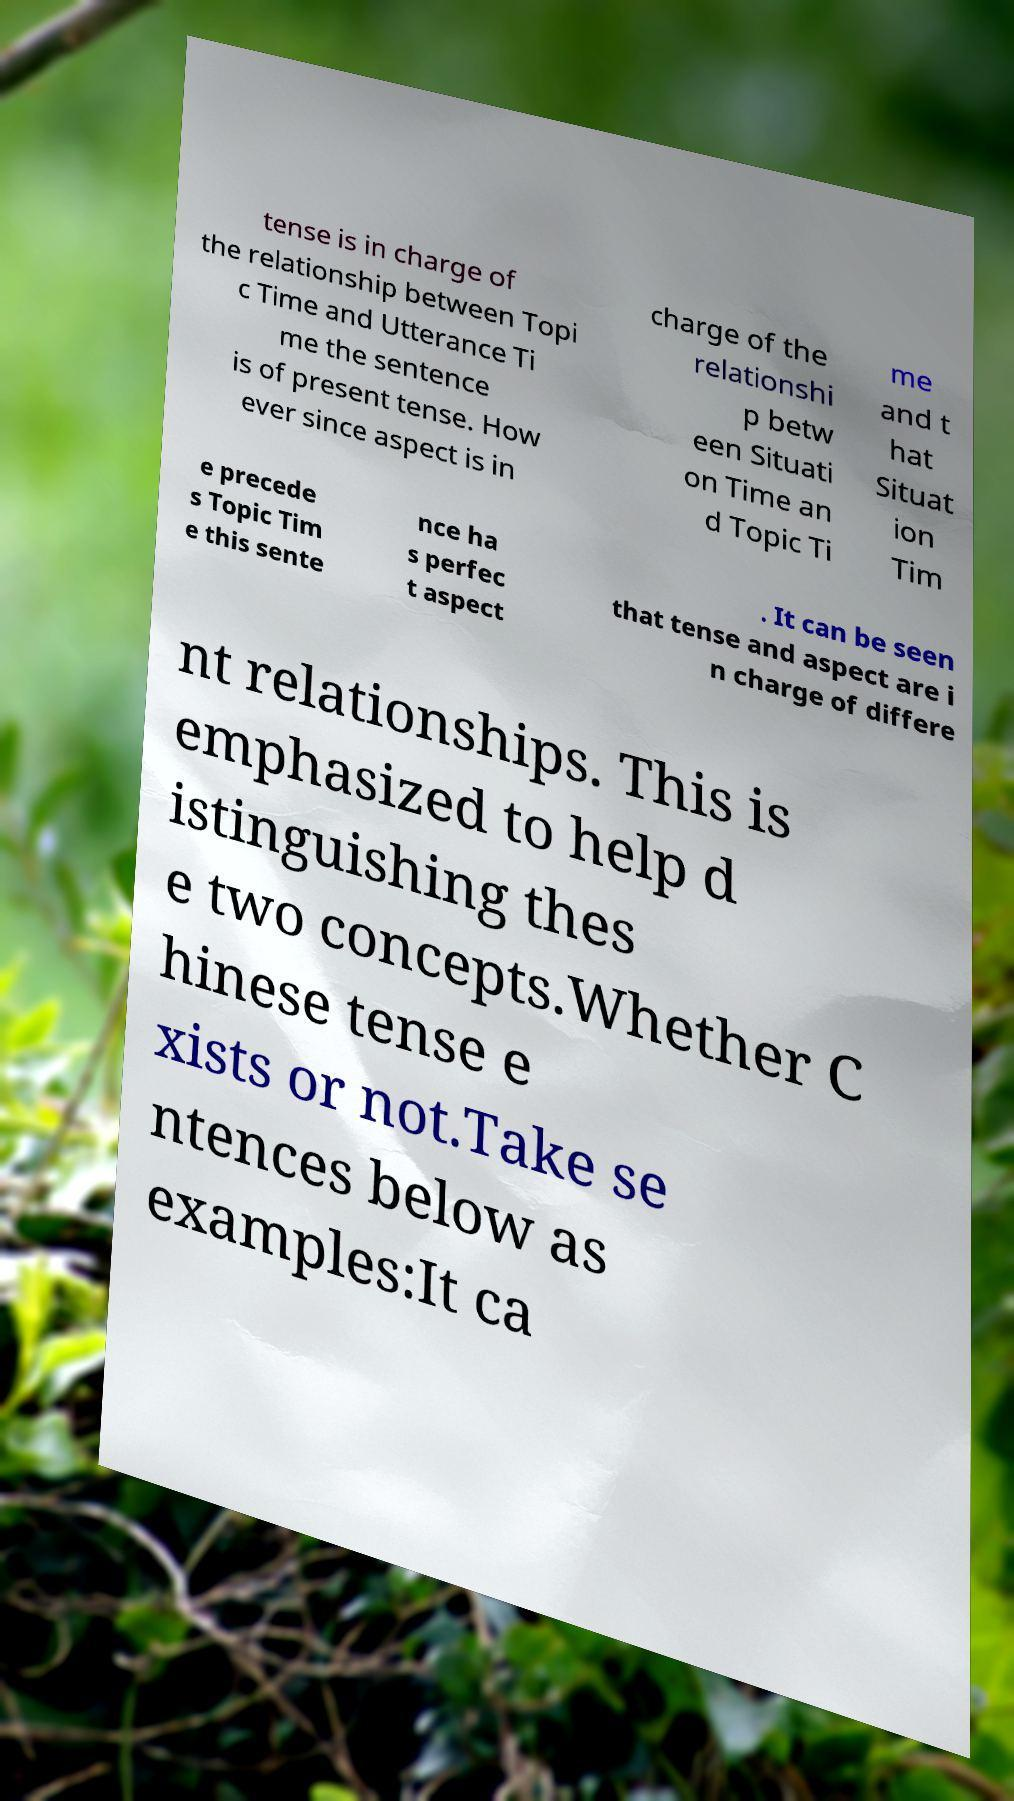Please read and relay the text visible in this image. What does it say? tense is in charge of the relationship between Topi c Time and Utterance Ti me the sentence is of present tense. How ever since aspect is in charge of the relationshi p betw een Situati on Time an d Topic Ti me and t hat Situat ion Tim e precede s Topic Tim e this sente nce ha s perfec t aspect . It can be seen that tense and aspect are i n charge of differe nt relationships. This is emphasized to help d istinguishing thes e two concepts.Whether C hinese tense e xists or not.Take se ntences below as examples:It ca 